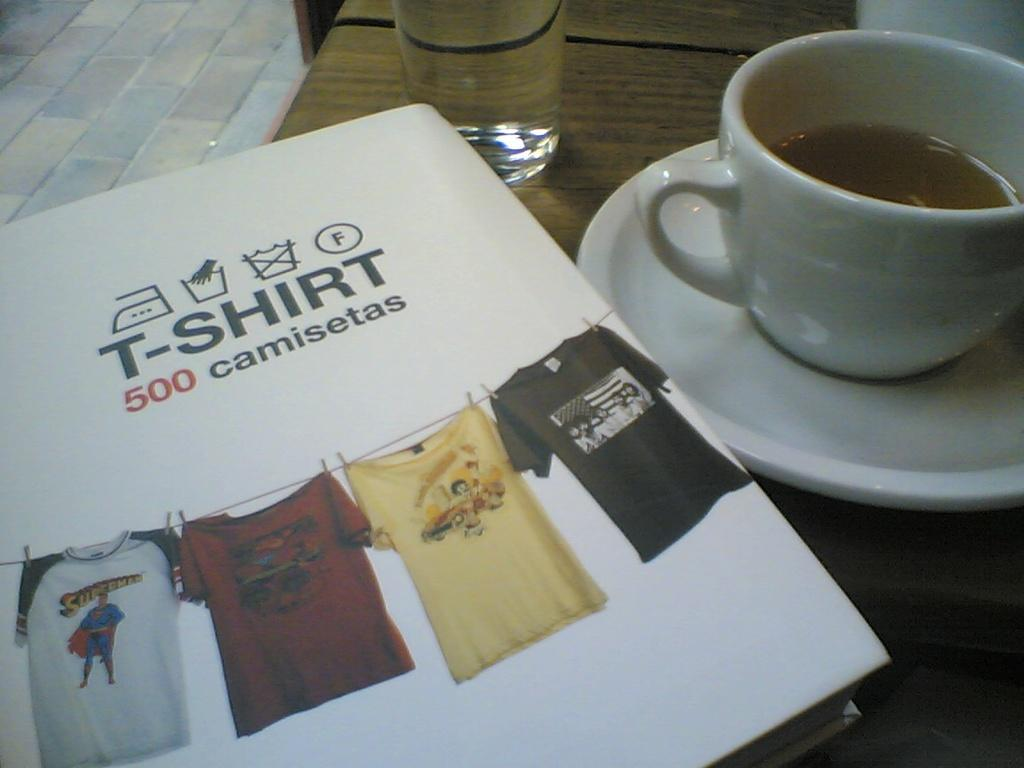Provide a one-sentence caption for the provided image. Coffee and a book called T-shirt 500 camisetas. 